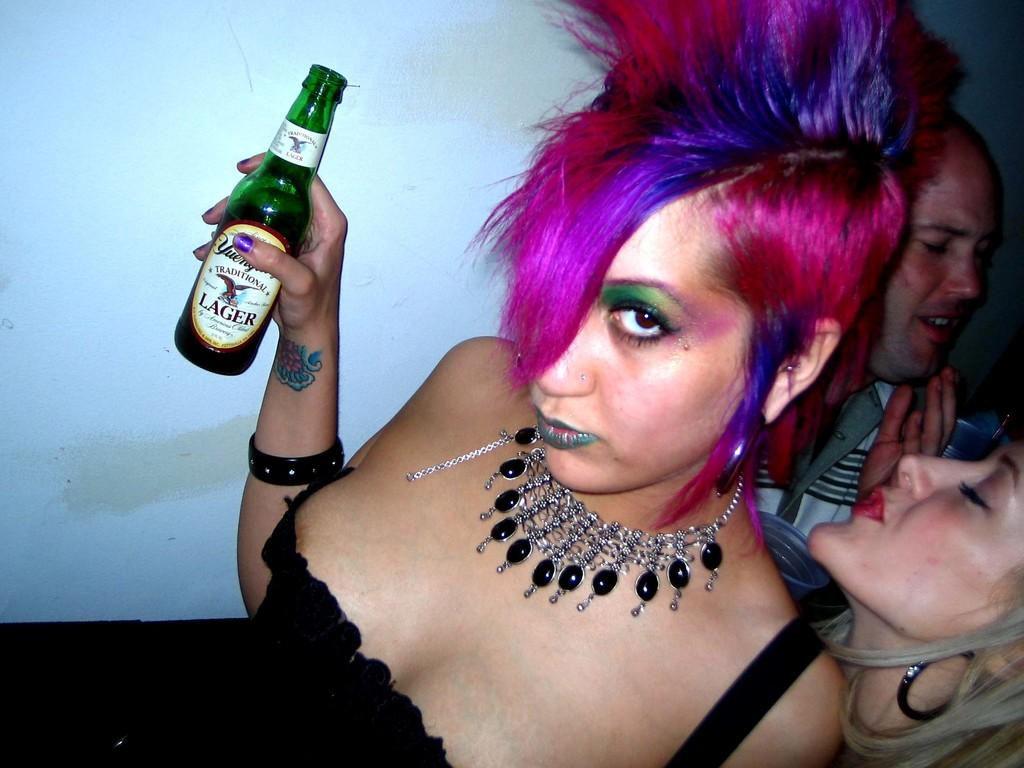What is a distinctive feature of the woman in the image? The woman in the image has pink hair. What is the woman holding in the image? The woman is holding an alcohol bottle. Can you describe another person in the image? Yes, there is a man in the image. Are there any children in the image? Yes, there is a girl in the image. What type of ice can be seen melting on the ground in the image? There is no ice present in the image; it only features a woman with pink hair, a man, a girl, and an alcohol bottle. How many dogs are visible in the image? There are no dogs present in the image. 